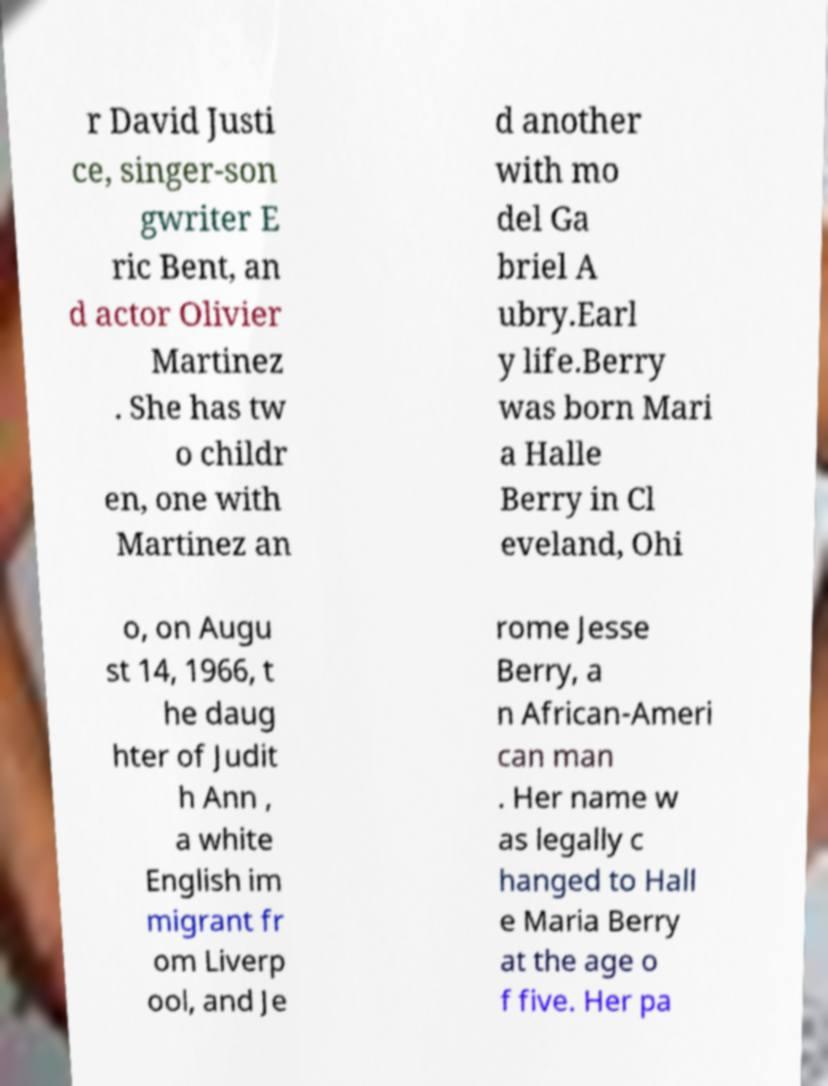Could you extract and type out the text from this image? r David Justi ce, singer-son gwriter E ric Bent, an d actor Olivier Martinez . She has tw o childr en, one with Martinez an d another with mo del Ga briel A ubry.Earl y life.Berry was born Mari a Halle Berry in Cl eveland, Ohi o, on Augu st 14, 1966, t he daug hter of Judit h Ann , a white English im migrant fr om Liverp ool, and Je rome Jesse Berry, a n African-Ameri can man . Her name w as legally c hanged to Hall e Maria Berry at the age o f five. Her pa 